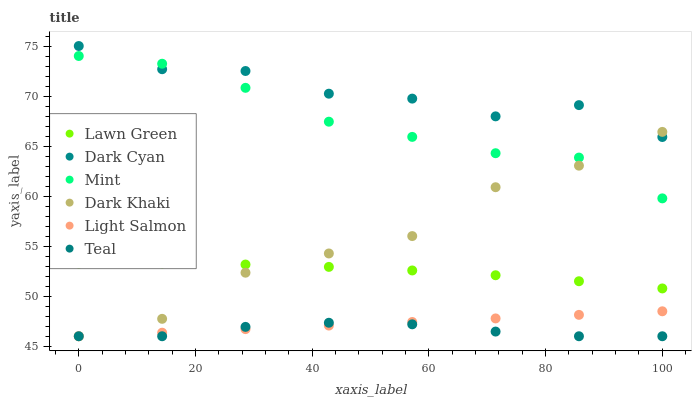Does Teal have the minimum area under the curve?
Answer yes or no. Yes. Does Dark Cyan have the maximum area under the curve?
Answer yes or no. Yes. Does Light Salmon have the minimum area under the curve?
Answer yes or no. No. Does Light Salmon have the maximum area under the curve?
Answer yes or no. No. Is Light Salmon the smoothest?
Answer yes or no. Yes. Is Dark Cyan the roughest?
Answer yes or no. Yes. Is Dark Khaki the smoothest?
Answer yes or no. No. Is Dark Khaki the roughest?
Answer yes or no. No. Does Light Salmon have the lowest value?
Answer yes or no. Yes. Does Dark Cyan have the lowest value?
Answer yes or no. No. Does Dark Cyan have the highest value?
Answer yes or no. Yes. Does Light Salmon have the highest value?
Answer yes or no. No. Is Teal less than Lawn Green?
Answer yes or no. Yes. Is Mint greater than Lawn Green?
Answer yes or no. Yes. Does Dark Khaki intersect Mint?
Answer yes or no. Yes. Is Dark Khaki less than Mint?
Answer yes or no. No. Is Dark Khaki greater than Mint?
Answer yes or no. No. Does Teal intersect Lawn Green?
Answer yes or no. No. 